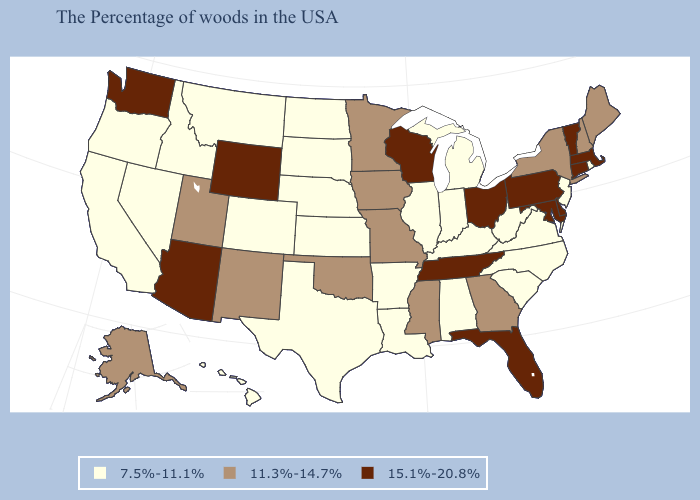Does Wyoming have the highest value in the USA?
Answer briefly. Yes. Name the states that have a value in the range 11.3%-14.7%?
Short answer required. Maine, New Hampshire, New York, Georgia, Mississippi, Missouri, Minnesota, Iowa, Oklahoma, New Mexico, Utah, Alaska. Among the states that border North Carolina , which have the highest value?
Answer briefly. Tennessee. Does South Dakota have the highest value in the MidWest?
Be succinct. No. Which states have the highest value in the USA?
Give a very brief answer. Massachusetts, Vermont, Connecticut, Delaware, Maryland, Pennsylvania, Ohio, Florida, Tennessee, Wisconsin, Wyoming, Arizona, Washington. What is the lowest value in the West?
Keep it brief. 7.5%-11.1%. What is the value of South Carolina?
Concise answer only. 7.5%-11.1%. Among the states that border Virginia , which have the highest value?
Write a very short answer. Maryland, Tennessee. What is the value of Arizona?
Be succinct. 15.1%-20.8%. Among the states that border Wyoming , which have the lowest value?
Be succinct. Nebraska, South Dakota, Colorado, Montana, Idaho. Does Ohio have a higher value than Texas?
Short answer required. Yes. Name the states that have a value in the range 11.3%-14.7%?
Quick response, please. Maine, New Hampshire, New York, Georgia, Mississippi, Missouri, Minnesota, Iowa, Oklahoma, New Mexico, Utah, Alaska. Which states have the lowest value in the USA?
Keep it brief. Rhode Island, New Jersey, Virginia, North Carolina, South Carolina, West Virginia, Michigan, Kentucky, Indiana, Alabama, Illinois, Louisiana, Arkansas, Kansas, Nebraska, Texas, South Dakota, North Dakota, Colorado, Montana, Idaho, Nevada, California, Oregon, Hawaii. What is the value of North Dakota?
Give a very brief answer. 7.5%-11.1%. 